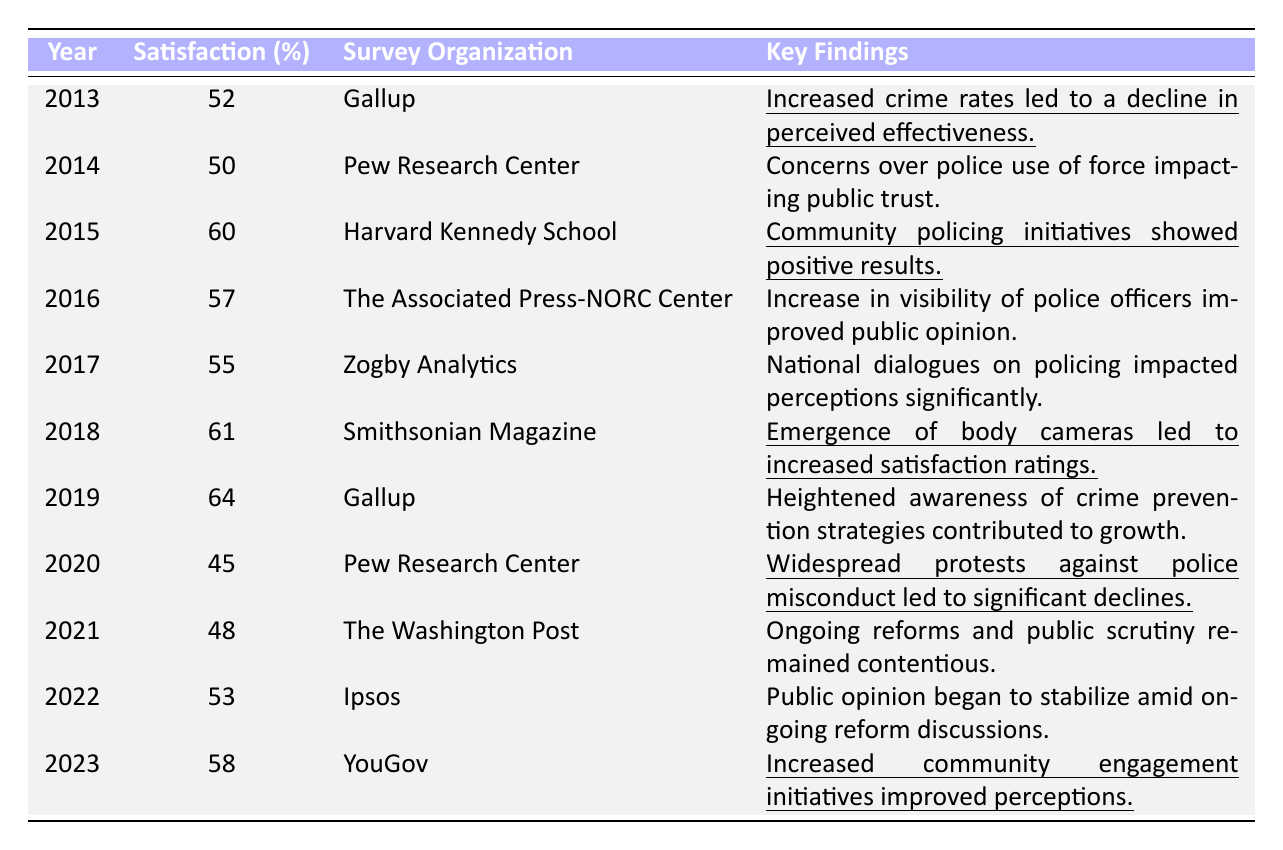What was the percentage satisfaction reported in 2015? In 2015, the table lists the percentage satisfaction as 60%.
Answer: 60% Which survey organization recorded the lowest satisfaction percentage and in what year? Pew Research Center recorded the lowest satisfaction percentage of 45% in 2020.
Answer: Pew Research Center, 2020 What was the change in satisfaction percentage from 2013 to 2019? The satisfaction in 2013 was 52%, and in 2019, it was 64%. The change is 64 - 52 = 12%.
Answer: 12% What percentage satisfied did the survey report in 2020 and how did it compare to 2019? In 2020, the percentage satisfied was 45%, which is a decrease from 2019's 64%. The difference is 64 - 45 = 19%.
Answer: 19% Which year had the highest recorded satisfaction percentage and what was it? The year 2019 had the highest recorded satisfaction percentage at 64%.
Answer: 2019, 64% From 2013 to 2023, what was the average satisfaction percentage? To find the average, we sum the percentages from each year: (52 + 50 + 60 + 57 + 55 + 61 + 64 + 45 + 48 + 53 + 58) = 611. There are 11 years, so the average is 611 / 11 = 55.545, which rounds to 55.5%.
Answer: 55.5% Which survey organization noted the impact of body cameras on public satisfaction? Smithsonian Magazine noted the emergence of body cameras and their positive effect on satisfaction in 2018.
Answer: Smithsonian Magazine Did the public perception of police effectiveness generally increase or decrease from 2013 to 2023? The public perception increased overall, starting from 52% in 2013 and rising to 58% in 2023, showing a positive trend.
Answer: Increased In which year did satisfaction begin to stabilize according to the data? Satisfaction began to stabilize in 2022 according to Ipsos' findings.
Answer: 2022 What key finding in 2020 led to a significant decline in satisfaction? The key finding in 2020 was widespread protests against police misconduct, which led to a significant decline in satisfaction.
Answer: Protests against police misconduct Which year showed the largest increase in satisfaction compared to the previous year? The largest increase was from 2018 to 2019, rising from 61% to 64%, which is an increase of 3%.
Answer: 3% increase from 2018 to 2019 